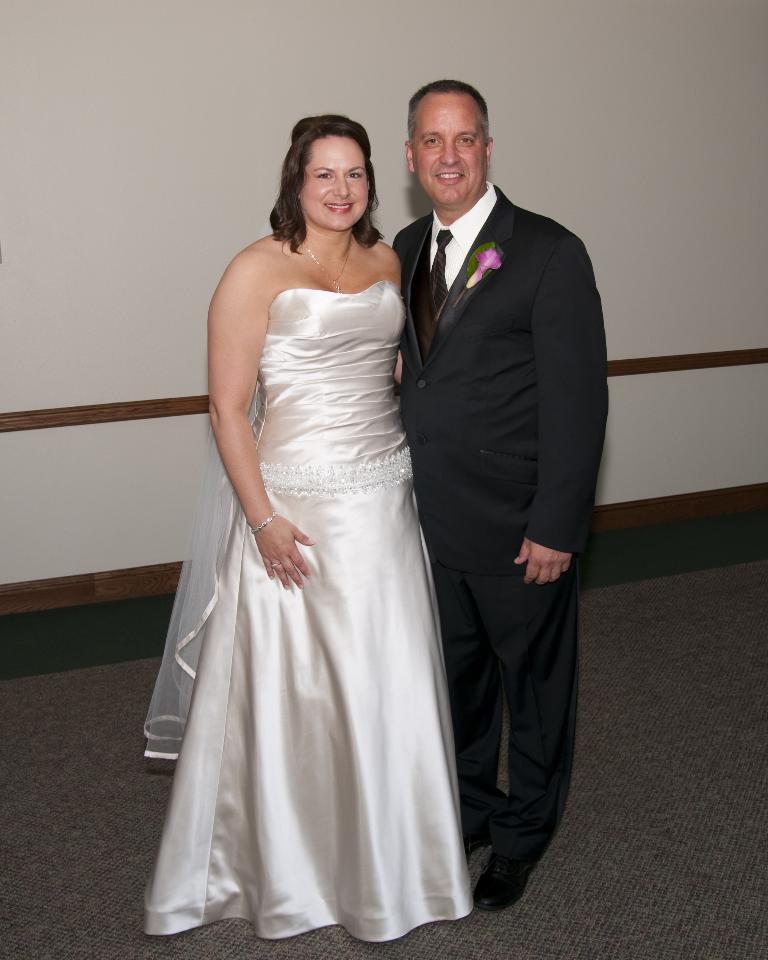Who are the people in the image? There is a man and a woman in the image. What are the expressions on their faces? Both the man and the woman are smiling. What can be seen in the background of the image? There is a wall in the background of the image. What is the man wearing? The man is wearing a suit. What type of glue is the man using to stick the train to the wall in the image? There is no train or glue present in the image; it features a man and a woman smiling in front of a wall. 